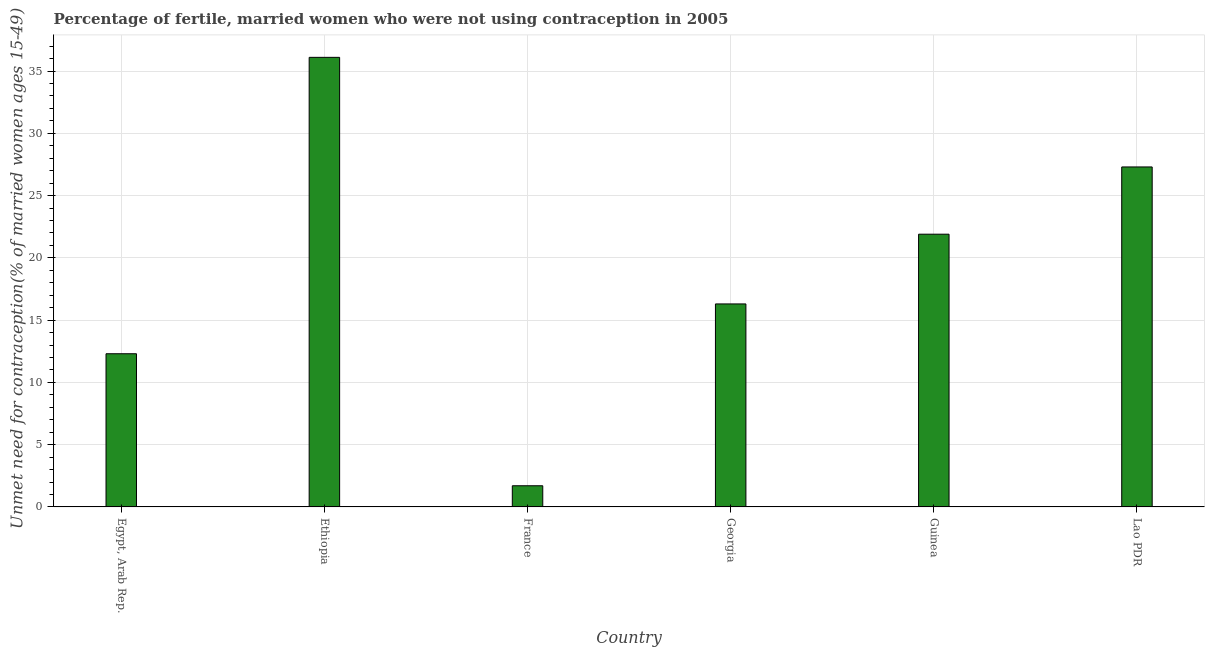What is the title of the graph?
Your answer should be compact. Percentage of fertile, married women who were not using contraception in 2005. What is the label or title of the X-axis?
Keep it short and to the point. Country. What is the label or title of the Y-axis?
Your response must be concise.  Unmet need for contraception(% of married women ages 15-49). What is the number of married women who are not using contraception in Lao PDR?
Offer a very short reply. 27.3. Across all countries, what is the maximum number of married women who are not using contraception?
Keep it short and to the point. 36.1. In which country was the number of married women who are not using contraception maximum?
Provide a short and direct response. Ethiopia. What is the sum of the number of married women who are not using contraception?
Give a very brief answer. 115.6. What is the average number of married women who are not using contraception per country?
Keep it short and to the point. 19.27. What is the ratio of the number of married women who are not using contraception in Ethiopia to that in Lao PDR?
Offer a very short reply. 1.32. Is the sum of the number of married women who are not using contraception in Egypt, Arab Rep. and Lao PDR greater than the maximum number of married women who are not using contraception across all countries?
Keep it short and to the point. Yes. What is the difference between the highest and the lowest number of married women who are not using contraception?
Keep it short and to the point. 34.4. In how many countries, is the number of married women who are not using contraception greater than the average number of married women who are not using contraception taken over all countries?
Your answer should be very brief. 3. Are all the bars in the graph horizontal?
Offer a terse response. No. How many countries are there in the graph?
Offer a very short reply. 6. What is the difference between two consecutive major ticks on the Y-axis?
Ensure brevity in your answer.  5. Are the values on the major ticks of Y-axis written in scientific E-notation?
Give a very brief answer. No. What is the  Unmet need for contraception(% of married women ages 15-49) of Ethiopia?
Keep it short and to the point. 36.1. What is the  Unmet need for contraception(% of married women ages 15-49) in France?
Your answer should be compact. 1.7. What is the  Unmet need for contraception(% of married women ages 15-49) in Georgia?
Ensure brevity in your answer.  16.3. What is the  Unmet need for contraception(% of married women ages 15-49) in Guinea?
Keep it short and to the point. 21.9. What is the  Unmet need for contraception(% of married women ages 15-49) of Lao PDR?
Offer a terse response. 27.3. What is the difference between the  Unmet need for contraception(% of married women ages 15-49) in Egypt, Arab Rep. and Ethiopia?
Ensure brevity in your answer.  -23.8. What is the difference between the  Unmet need for contraception(% of married women ages 15-49) in Egypt, Arab Rep. and Guinea?
Ensure brevity in your answer.  -9.6. What is the difference between the  Unmet need for contraception(% of married women ages 15-49) in Egypt, Arab Rep. and Lao PDR?
Your answer should be compact. -15. What is the difference between the  Unmet need for contraception(% of married women ages 15-49) in Ethiopia and France?
Offer a very short reply. 34.4. What is the difference between the  Unmet need for contraception(% of married women ages 15-49) in Ethiopia and Georgia?
Your answer should be very brief. 19.8. What is the difference between the  Unmet need for contraception(% of married women ages 15-49) in Ethiopia and Guinea?
Keep it short and to the point. 14.2. What is the difference between the  Unmet need for contraception(% of married women ages 15-49) in France and Georgia?
Offer a terse response. -14.6. What is the difference between the  Unmet need for contraception(% of married women ages 15-49) in France and Guinea?
Give a very brief answer. -20.2. What is the difference between the  Unmet need for contraception(% of married women ages 15-49) in France and Lao PDR?
Give a very brief answer. -25.6. What is the difference between the  Unmet need for contraception(% of married women ages 15-49) in Georgia and Guinea?
Ensure brevity in your answer.  -5.6. What is the difference between the  Unmet need for contraception(% of married women ages 15-49) in Georgia and Lao PDR?
Provide a succinct answer. -11. What is the difference between the  Unmet need for contraception(% of married women ages 15-49) in Guinea and Lao PDR?
Your response must be concise. -5.4. What is the ratio of the  Unmet need for contraception(% of married women ages 15-49) in Egypt, Arab Rep. to that in Ethiopia?
Offer a very short reply. 0.34. What is the ratio of the  Unmet need for contraception(% of married women ages 15-49) in Egypt, Arab Rep. to that in France?
Your response must be concise. 7.24. What is the ratio of the  Unmet need for contraception(% of married women ages 15-49) in Egypt, Arab Rep. to that in Georgia?
Give a very brief answer. 0.76. What is the ratio of the  Unmet need for contraception(% of married women ages 15-49) in Egypt, Arab Rep. to that in Guinea?
Give a very brief answer. 0.56. What is the ratio of the  Unmet need for contraception(% of married women ages 15-49) in Egypt, Arab Rep. to that in Lao PDR?
Keep it short and to the point. 0.45. What is the ratio of the  Unmet need for contraception(% of married women ages 15-49) in Ethiopia to that in France?
Make the answer very short. 21.23. What is the ratio of the  Unmet need for contraception(% of married women ages 15-49) in Ethiopia to that in Georgia?
Keep it short and to the point. 2.21. What is the ratio of the  Unmet need for contraception(% of married women ages 15-49) in Ethiopia to that in Guinea?
Provide a short and direct response. 1.65. What is the ratio of the  Unmet need for contraception(% of married women ages 15-49) in Ethiopia to that in Lao PDR?
Make the answer very short. 1.32. What is the ratio of the  Unmet need for contraception(% of married women ages 15-49) in France to that in Georgia?
Provide a short and direct response. 0.1. What is the ratio of the  Unmet need for contraception(% of married women ages 15-49) in France to that in Guinea?
Keep it short and to the point. 0.08. What is the ratio of the  Unmet need for contraception(% of married women ages 15-49) in France to that in Lao PDR?
Your response must be concise. 0.06. What is the ratio of the  Unmet need for contraception(% of married women ages 15-49) in Georgia to that in Guinea?
Your answer should be very brief. 0.74. What is the ratio of the  Unmet need for contraception(% of married women ages 15-49) in Georgia to that in Lao PDR?
Offer a very short reply. 0.6. What is the ratio of the  Unmet need for contraception(% of married women ages 15-49) in Guinea to that in Lao PDR?
Keep it short and to the point. 0.8. 